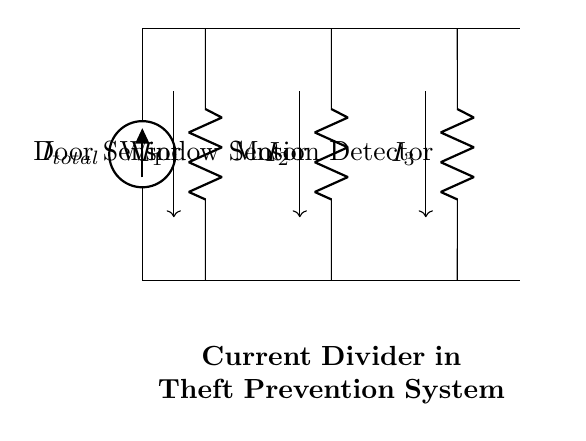What type of circuit is represented in this diagram? The diagram represents a parallel circuit configuration where multiple components are connected across the same two nodes. This allows for the current to divide among the branches.
Answer: Parallel What does R1 represent in this circuit? R1 is labeled as the Door Sensor, indicating its function within the theft prevention system to monitor the door for any unauthorized entry.
Answer: Door Sensor How many sensors are present in the circuit? The circuit diagram includes three sensors: a Door Sensor, a Window Sensor, and a Motion Detector. This information can be gathered by counting the resistors labeled in the diagram.
Answer: Three What is the significance of current division in this application? Current division allows each sensor to receive a specific portion of the total current, which ensures they operate effectively and can provide accurate readings for the security system. This is crucial in ensuring that each sensor has enough sensitivity to detect intrusions.
Answer: Efficient operation If R2 has a resistance of 10 ohms and R1 has a resistance of 5 ohms, what can be said about the currents I1 and I2? According to the current divider rule, the current through a resistor in parallel is inversely proportional to its resistance. Therefore, I1 will be greater than I2 since R1 is less than R2. This indicates that the Door Sensor (R1) will have more current passing through it compared to the Window Sensor (R2).
Answer: I1 > I2 Which sensor is likely to detect motion based on the labels? The circuit diagram indicates that the Motion Detector is labeled as R3, which is specifically designed to monitor movement, making it the sensor most likely to detect motion.
Answer: Motion Detector 